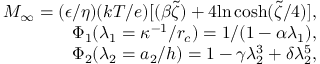Convert formula to latex. <formula><loc_0><loc_0><loc_500><loc_500>\begin{array} { r } { M _ { \infty } = ( \epsilon / \eta ) ( k T / e ) [ ( \beta \widetilde { \zeta } ) + 4 \ln \, \cosh ( \widetilde { \zeta } / 4 ) ] , } \\ { \Phi _ { 1 } ( \lambda _ { 1 } = \kappa ^ { - 1 } / r _ { c } ) = 1 / ( 1 - \alpha \lambda _ { 1 } ) , } \\ { \Phi _ { 2 } ( \lambda _ { 2 } = a _ { 2 } / h ) = 1 - \gamma \lambda _ { 2 } ^ { 3 } + \delta \lambda _ { 2 } ^ { 5 } , } \end{array}</formula> 